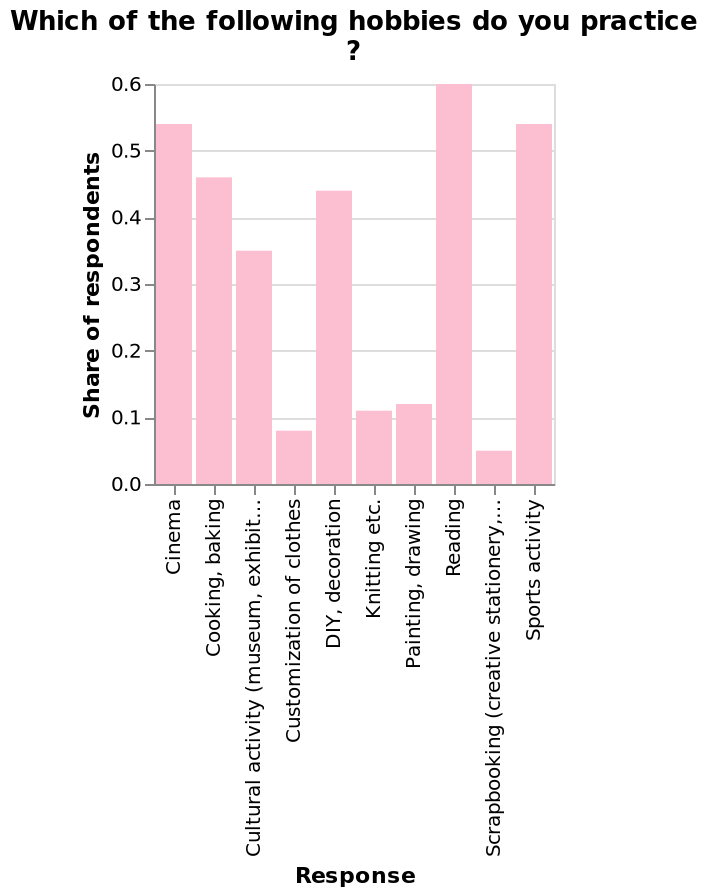<image>
Which two activities are tied in second place according to the survey? Cinema and Sports are tied in second place with a share around 0.54. What is the share of respondents who enjoy Cinema and Sports? Cinema and Sports both have a share around 0.54 among the respondents. What is the range of the scale along the y-axis in the bar diagram? The range of the scale along the y-axis in the bar diagram is from 0.0 to 0.6. 